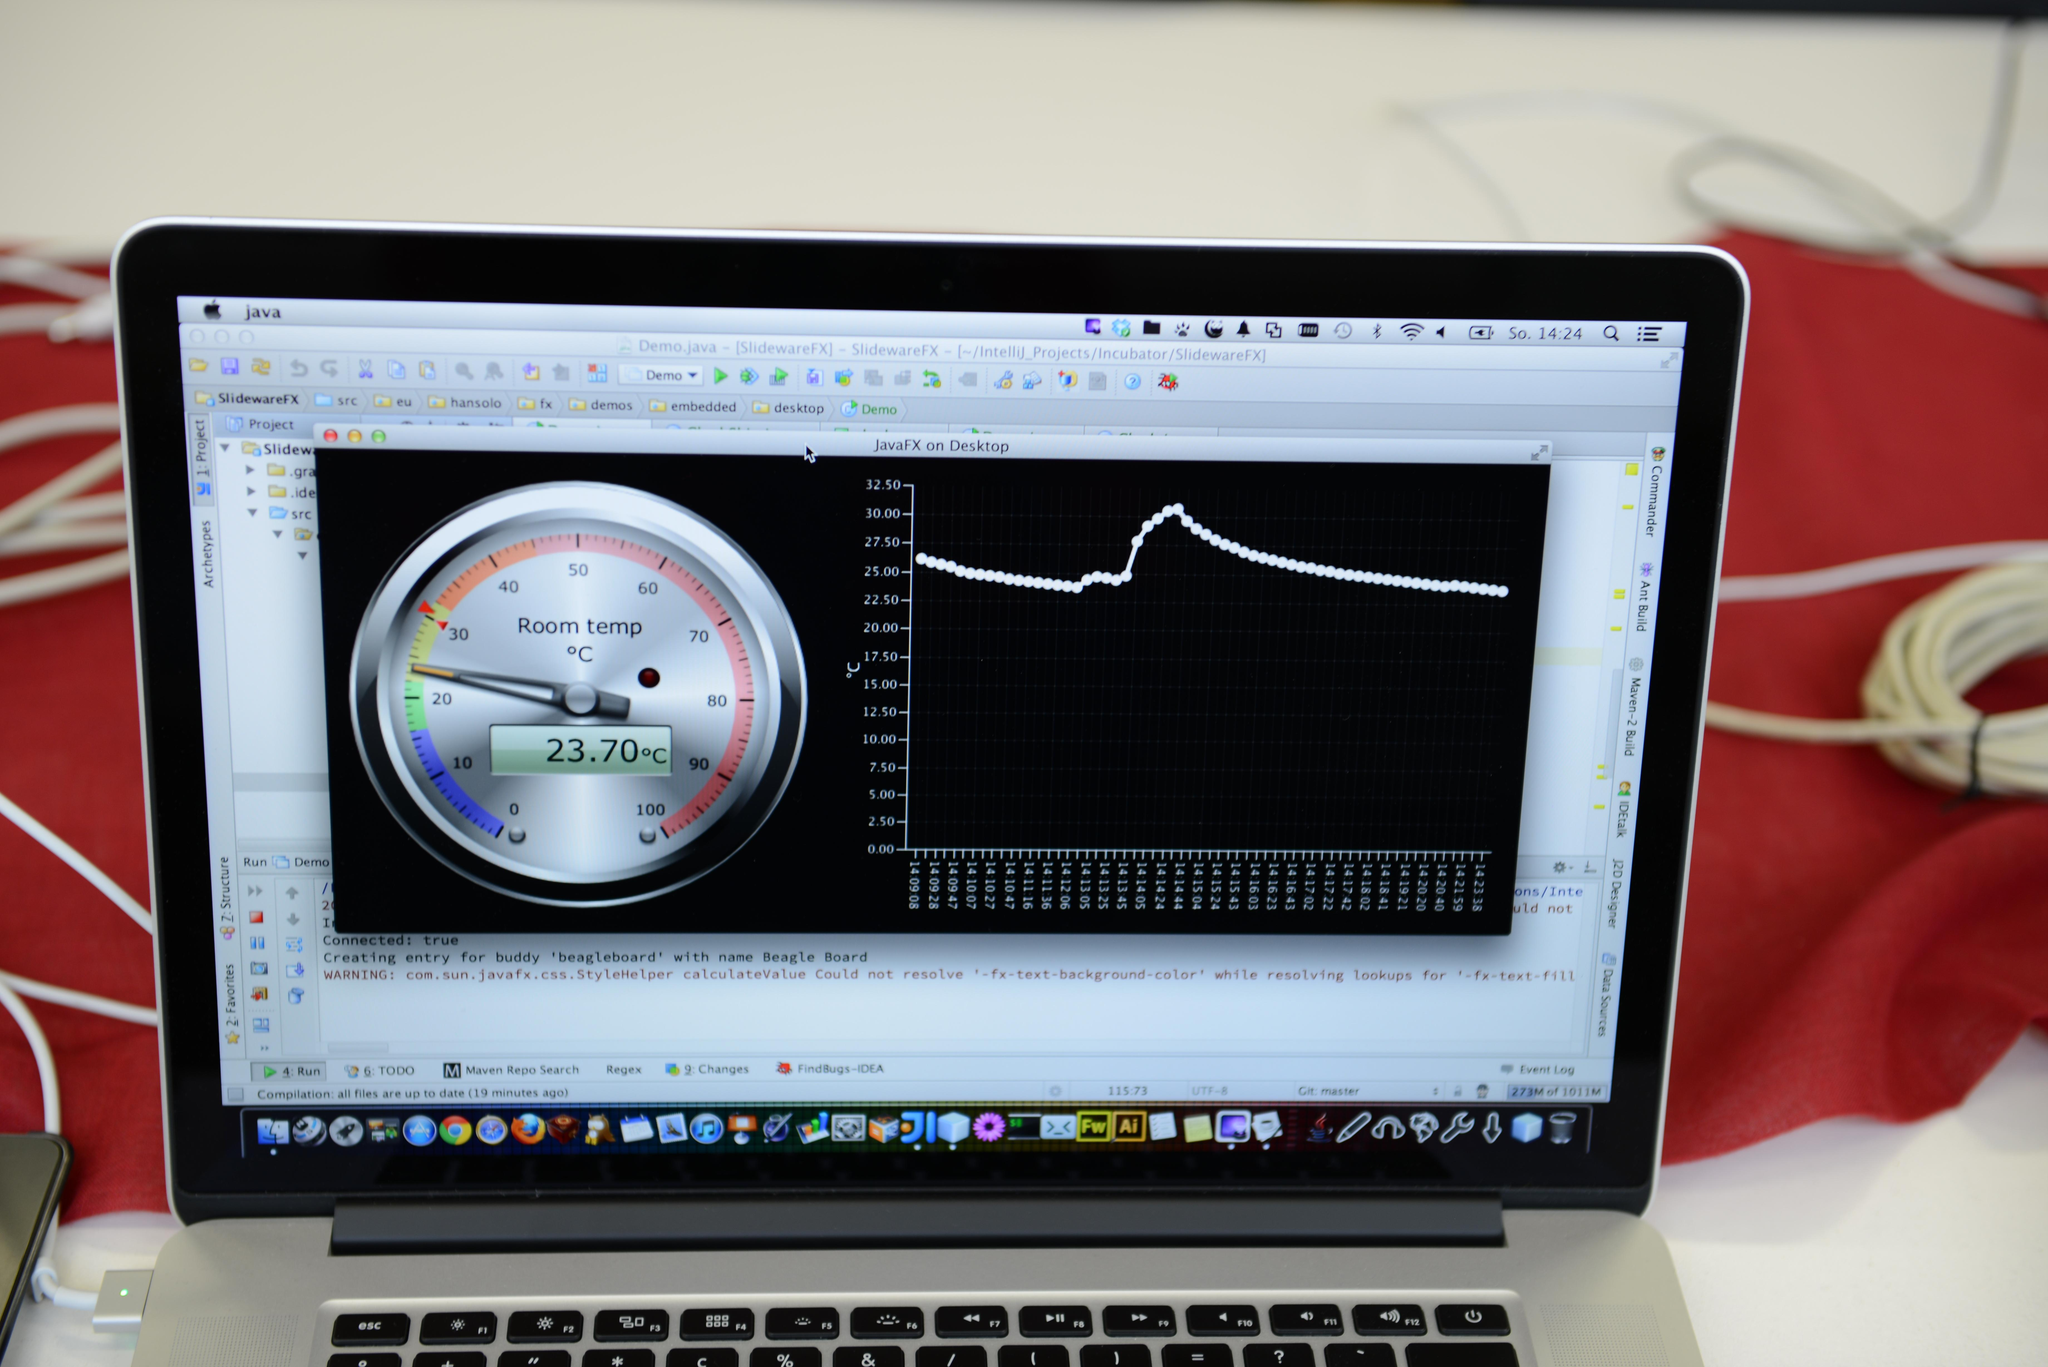What electronic device is visible in the image? There is a laptop in the image. What is displayed on the laptop screen? The laptop screen displays temperature statistics. Can you describe any additional objects or features in the image? There is a cable on the right side of the image. What type of acoustics can be heard coming from the laptop in the image? There is no indication of any sound or acoustics coming from the laptop in the image. 